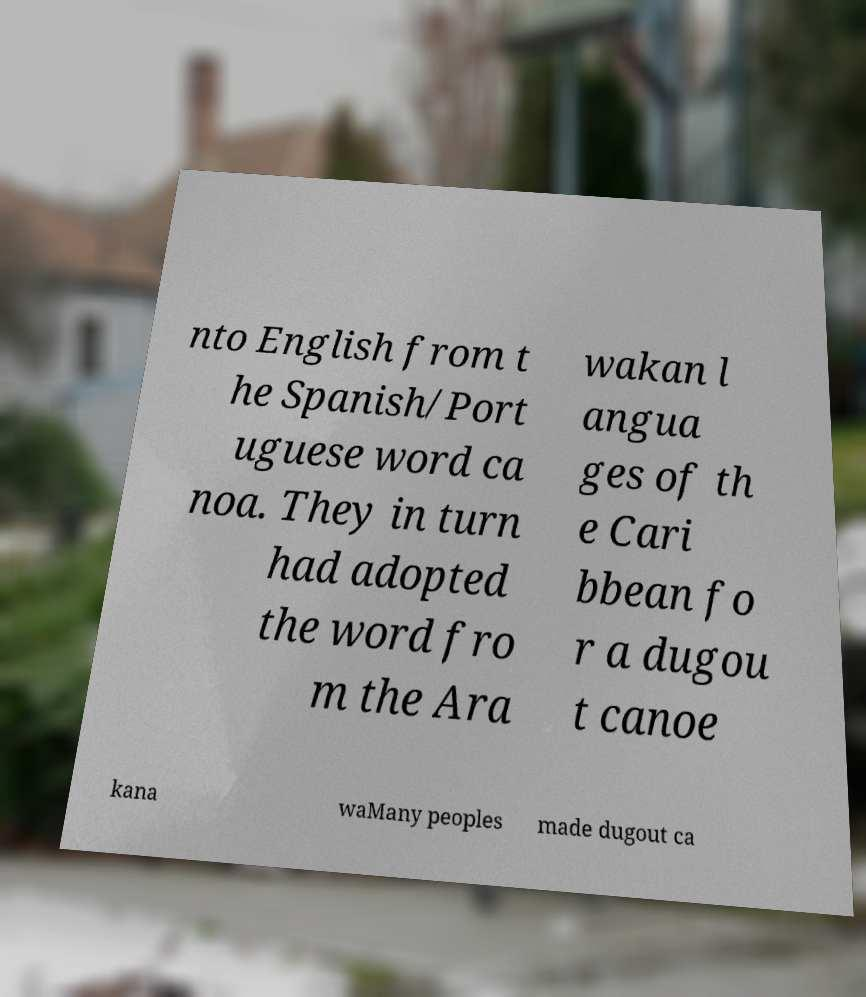Can you accurately transcribe the text from the provided image for me? nto English from t he Spanish/Port uguese word ca noa. They in turn had adopted the word fro m the Ara wakan l angua ges of th e Cari bbean fo r a dugou t canoe kana waMany peoples made dugout ca 